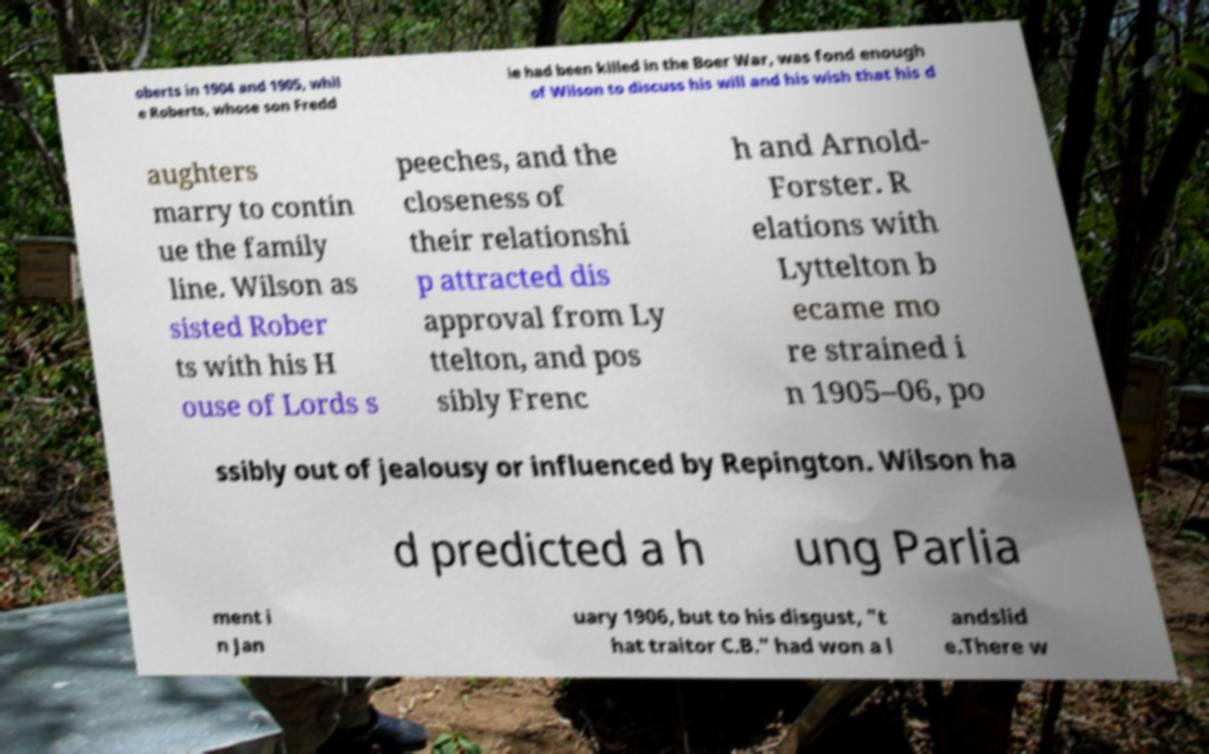Could you assist in decoding the text presented in this image and type it out clearly? oberts in 1904 and 1905, whil e Roberts, whose son Fredd ie had been killed in the Boer War, was fond enough of Wilson to discuss his will and his wish that his d aughters marry to contin ue the family line. Wilson as sisted Rober ts with his H ouse of Lords s peeches, and the closeness of their relationshi p attracted dis approval from Ly ttelton, and pos sibly Frenc h and Arnold- Forster. R elations with Lyttelton b ecame mo re strained i n 1905–06, po ssibly out of jealousy or influenced by Repington. Wilson ha d predicted a h ung Parlia ment i n Jan uary 1906, but to his disgust, "t hat traitor C.B." had won a l andslid e.There w 